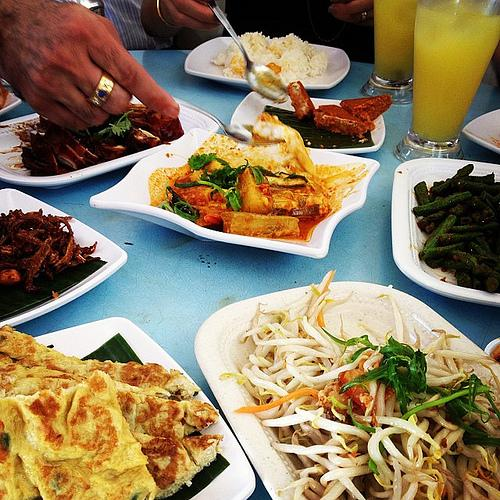Describe the setting and mood of the image as if you were telling a story. At a dinner party on a blue table, guests were enjoying a variety of multi-colored dishes, with one of them wearing a beautiful ring while using a silver spoon to savor the food. What is the dominant color of the table in the image? The dominant color of the table in the image is blue. Mention any jewelry item present in the image and provide details about it. There is a large gold and silver ring with a blue gemstone, worn on a man's finger. Estimate the number of plates filled with food in the image. There are approximately 13 plates filled with food in the image. Identify the main food item in the image and describe its appearance. The main food item is a plate of rice, which appears white and is presented on a square white plate. Provide an emotion or sentiment that this image may evoke. This image may evoke a sense of hunger or a desire to eat a meal. How many different objects are interacting with the hand in the image? The hand in the image is interacting with two different objects: a silver spoon and a gold ring worn on a finger. List three types of vegetables present in the plates and their color. Brown and white fried bread, dark green onions, and small white bran sprouts. Explain the position of the spoon in the image. The spoon is being held by a hand and is being lowered towards the food, with its handle being wrapped by fingers. Identify and describe two beverages that appear in the image. Two tall glasses of orange liquid appear in the image, one of which is a glass of bright orange juice with ice. Where is the purple napkin with a floral pattern underneath the plate of rice? The napkin adds color and elegance to the table setting. The instructions are misleading because there is no mention of a purple napkin in the object annotations. The use of various language styles (interrogative and declarative sentences) makes it seem like a genuine request for locating the object in the image. Notice the brown leather wallet beside the hand of the man. The man might have been paying for the meal before eating. This instruction is misleading as no object in the image mentions a wallet. The combination of asking the reader to notice the wallet (declarative) and providing a plausible context for its presence in the image (interrogative) makes the statement seem more believable. Identify the small red apple sitting beside the multi-colored food on the plate. The apple adds a touch of sweetness to the meal. No annotation mentions an apple in the image. The interrogative sentence asks the reader to identify the apple, while the declarative sentence describes the apple's purpose, which makes it seem more plausible. Can you please locate the pink cupcake with a cherry on top in the image? There should be a pink cupcake on the table with the other plates of food. The instructions are misleading because there is no mention of a pink cupcake in the given object annotations. Additionally, the use of both an interrogative sentence (asking the user to locate the object) and a declarative sentence (claiming the object is on the table) makes it seem plausible. Try to find a plate of spaghetti bolognese next to the glass of orange liquid. It's a delicious plate of pasta with meat sauce. This instruction is misleading because no object in the image is related to spaghetti bolognese. The combination of a request to find the object (interrogative) and a declarative sentence describing the object makes the statement appear more credible. Can you find a plate of sushi rolls with avocado and salmon? The sushi should be placed on a wooden tray close to the plate of green vegetables. None of the objects in the given annotations mention sushi rolls or wooden trays. The interrogative sentence requests the user to locate the object, while the declarative sentence reinforcing its possible existence by associating it with an actual object (green vegetables) makes the statement misleading. 